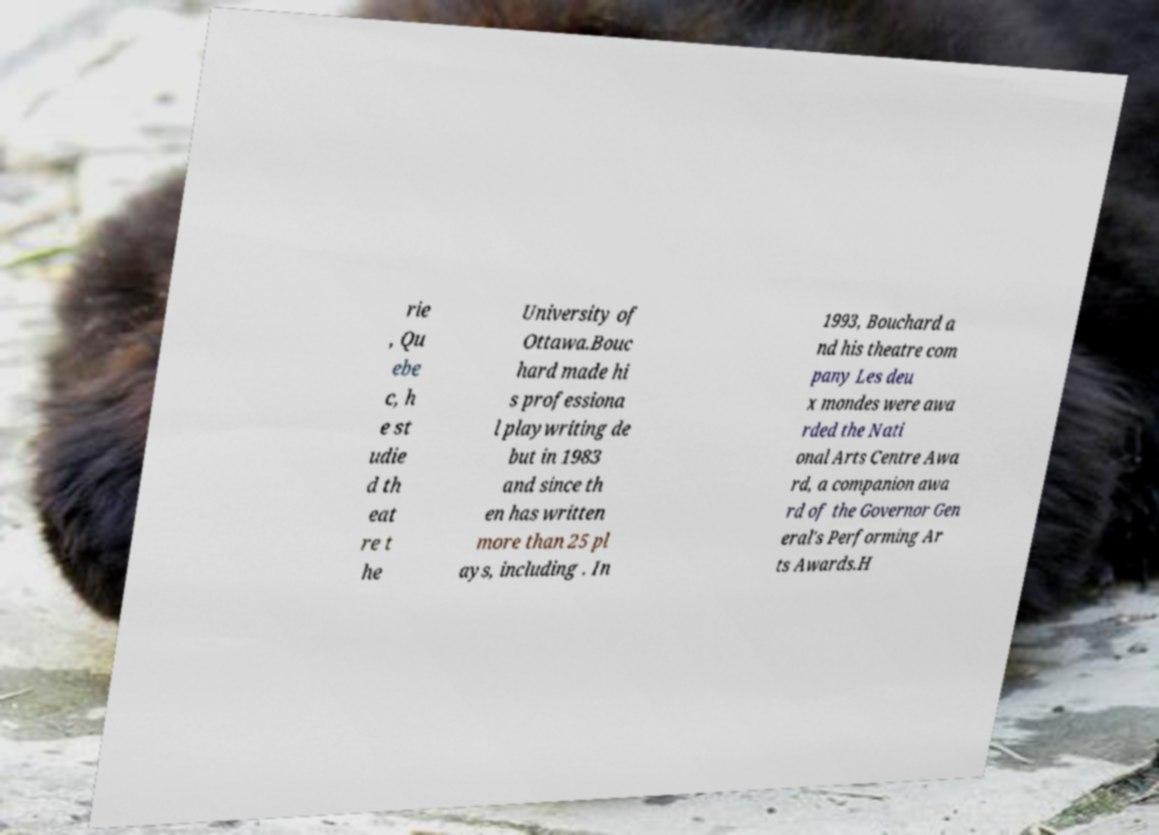Please read and relay the text visible in this image. What does it say? rie , Qu ebe c, h e st udie d th eat re t he University of Ottawa.Bouc hard made hi s professiona l playwriting de but in 1983 and since th en has written more than 25 pl ays, including . In 1993, Bouchard a nd his theatre com pany Les deu x mondes were awa rded the Nati onal Arts Centre Awa rd, a companion awa rd of the Governor Gen eral's Performing Ar ts Awards.H 